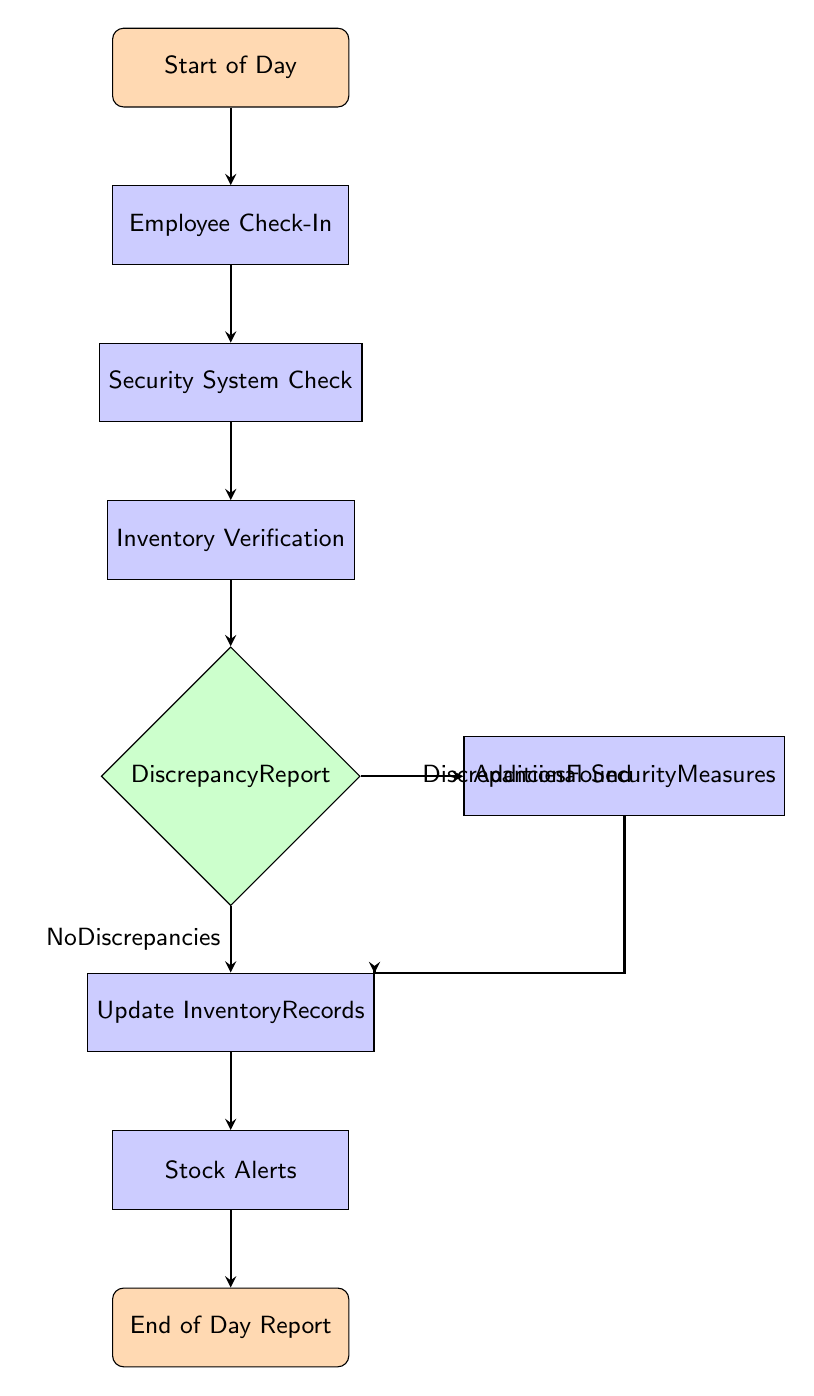What is the first node in the flow chart? The flow chart begins with the "Start of Day" node, which indicates the initiation of the daily inventory management process.
Answer: Start of Day How many decision nodes are present in the flow chart? The flow chart contains one decision node, which is the "Discrepancy Report" that leads to two possible branches based on whether discrepancies are found or not.
Answer: 1 What is the last process node before the end of the flow chart? The last process node before reaching the "End of Day Report" node is "Stock Alerts," as it follows the step of updating inventory records.
Answer: Stock Alerts If discrepancies are found, what is the next step? If discrepancies are found, the next step is to implement "Additional Security Measures" as indicated by the branch from the "Discrepancy Report" decision node.
Answer: Additional Security Measures What is done after verifying the security system? After verifying the security system, the next action is to conduct "Inventory Verification," which involves cross-checking physical inventory against digital records.
Answer: Inventory Verification What happens if no discrepancies are found? If no discrepancies are found, the flow continues to the "Update Inventory Records" process, which ensures accurate records are maintained in the system.
Answer: Update Inventory Records In total, how many process nodes are there? The flow chart consists of five process nodes: "Employee Check-In," "Security System Check," "Inventory Verification," "Update Inventory Records," and "Stock Alerts."
Answer: 5 What action is documented when discrepancies are found? When discrepancies are found, the action documented is the "Discrepancy Report," indicating the inconsistencies observed in the inventory that must be reported to the manager.
Answer: Discrepancy Report 